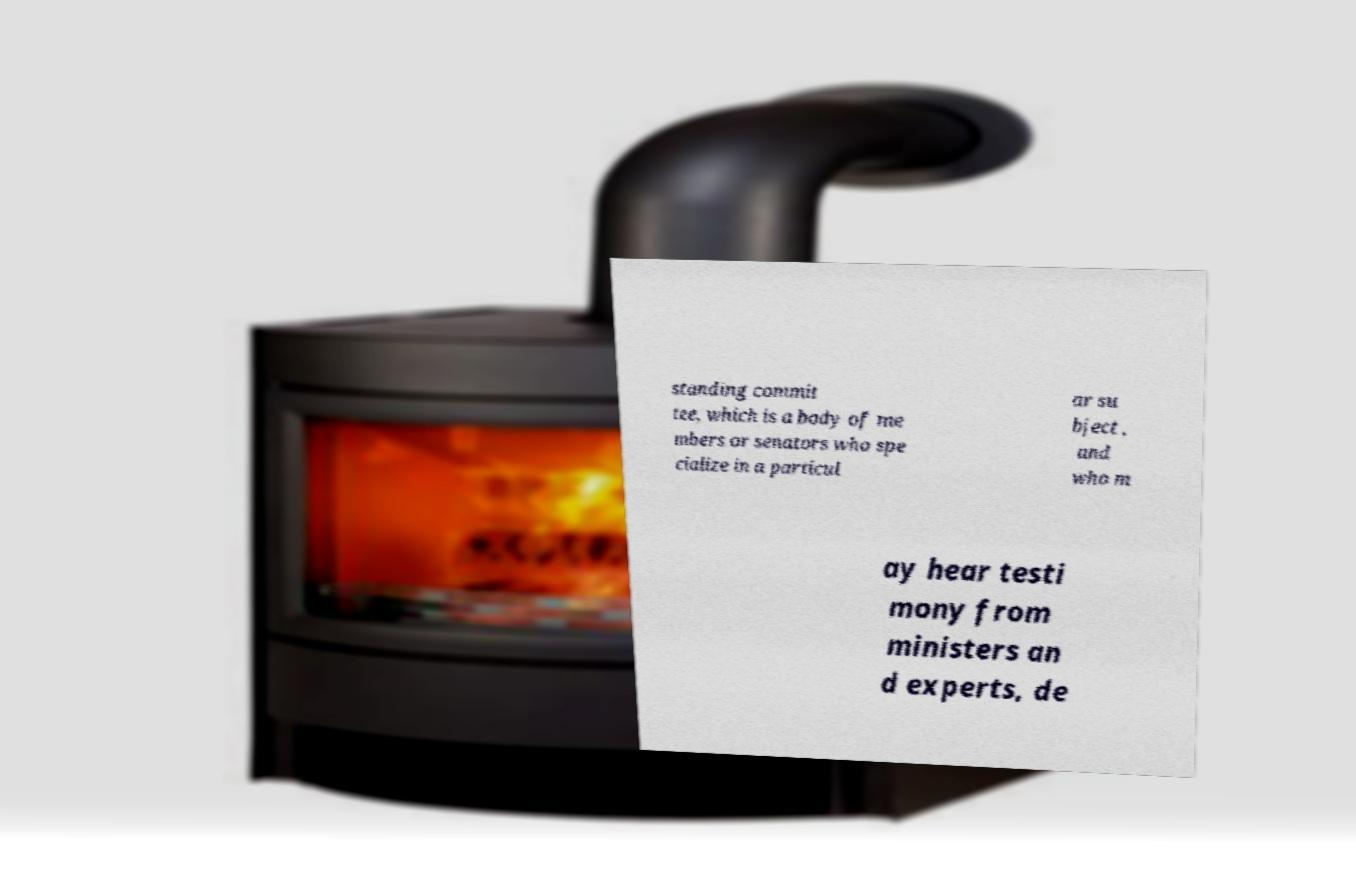There's text embedded in this image that I need extracted. Can you transcribe it verbatim? standing commit tee, which is a body of me mbers or senators who spe cialize in a particul ar su bject , and who m ay hear testi mony from ministers an d experts, de 